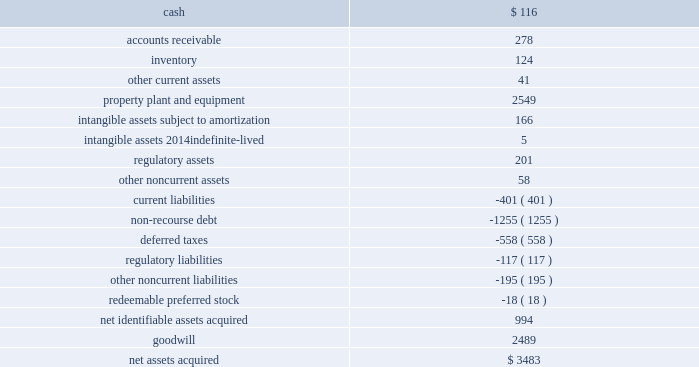The aes corporation notes to consolidated financial statements 2014 ( continued ) december 31 , 2011 , 2010 , and 2009 the preliminary allocation of the purchase price to the fair value of assets acquired and liabilities assumed is as follows ( in millions ) : .
At december 31 , 2011 , the assets acquired and liabilities assumed in the acquisition were recorded at provisional amounts based on the preliminary purchase price allocation .
The company is in the process of obtaining additional information to identify and measure all assets acquired and liabilities assumed in the acquisition within the measurement period , which could be up to one year from the date of acquisition .
Such provisional amounts will be retrospectively adjusted to reflect any new information about facts and circumstances that existed at the acquisition date that , if known , would have affected the measurement of these amounts .
Additionally , key input assumptions and their sensitivity to the valuation of assets acquired and liabilities assumed are currently being reviewed by management .
It is likely that the value of the generation business related property , plant and equipment , the intangible asset related to the electric security plan with its regulated customers and long-term coal contracts , the 4.9% ( 4.9 % ) equity ownership interest in the ohio valley electric corporation , and deferred taxes could change as the valuation process is finalized .
Dpler , dpl 2019s wholly-owned competitive retail electric service ( 201ccres 201d ) provider , will also likely have changes in its initial purchase price allocation for the valuation of its intangible assets for the trade name , and customer relationships and contracts .
As noted in the table above , the preliminary purchase price allocation has resulted in the recognition of $ 2.5 billion of goodwill .
Factors primarily contributing to a price in excess of the fair value of the net tangible and intangible assets include , but are not limited to : the ability to expand the u.s .
Utility platform in the mid-west market , the ability to capitalize on utility management experience gained from ipl , enhanced ability to negotiate with suppliers of fuel and energy , the ability to capture value associated with aes 2019 u.s .
Tax position , a well- positioned generating fleet , the ability of dpl to leverage its assembled workforce to take advantage of growth opportunities , etc .
Our ability to realize the benefit of dpl 2019s goodwill depends on the realization of expected benefits resulting from a successful integration of dpl into aes 2019 existing operations and our ability to respond to the changes in the ohio utility market .
For example , utilities in ohio continue to face downward pressure on operating margins due to the evolving regulatory environment , which is moving towards a market-based competitive pricing mechanism .
At the same time , the declining energy prices are also reducing operating .
What percentage on net assets acquired is due to goodwill? 
Computations: (2489 / 3483)
Answer: 0.71461. 